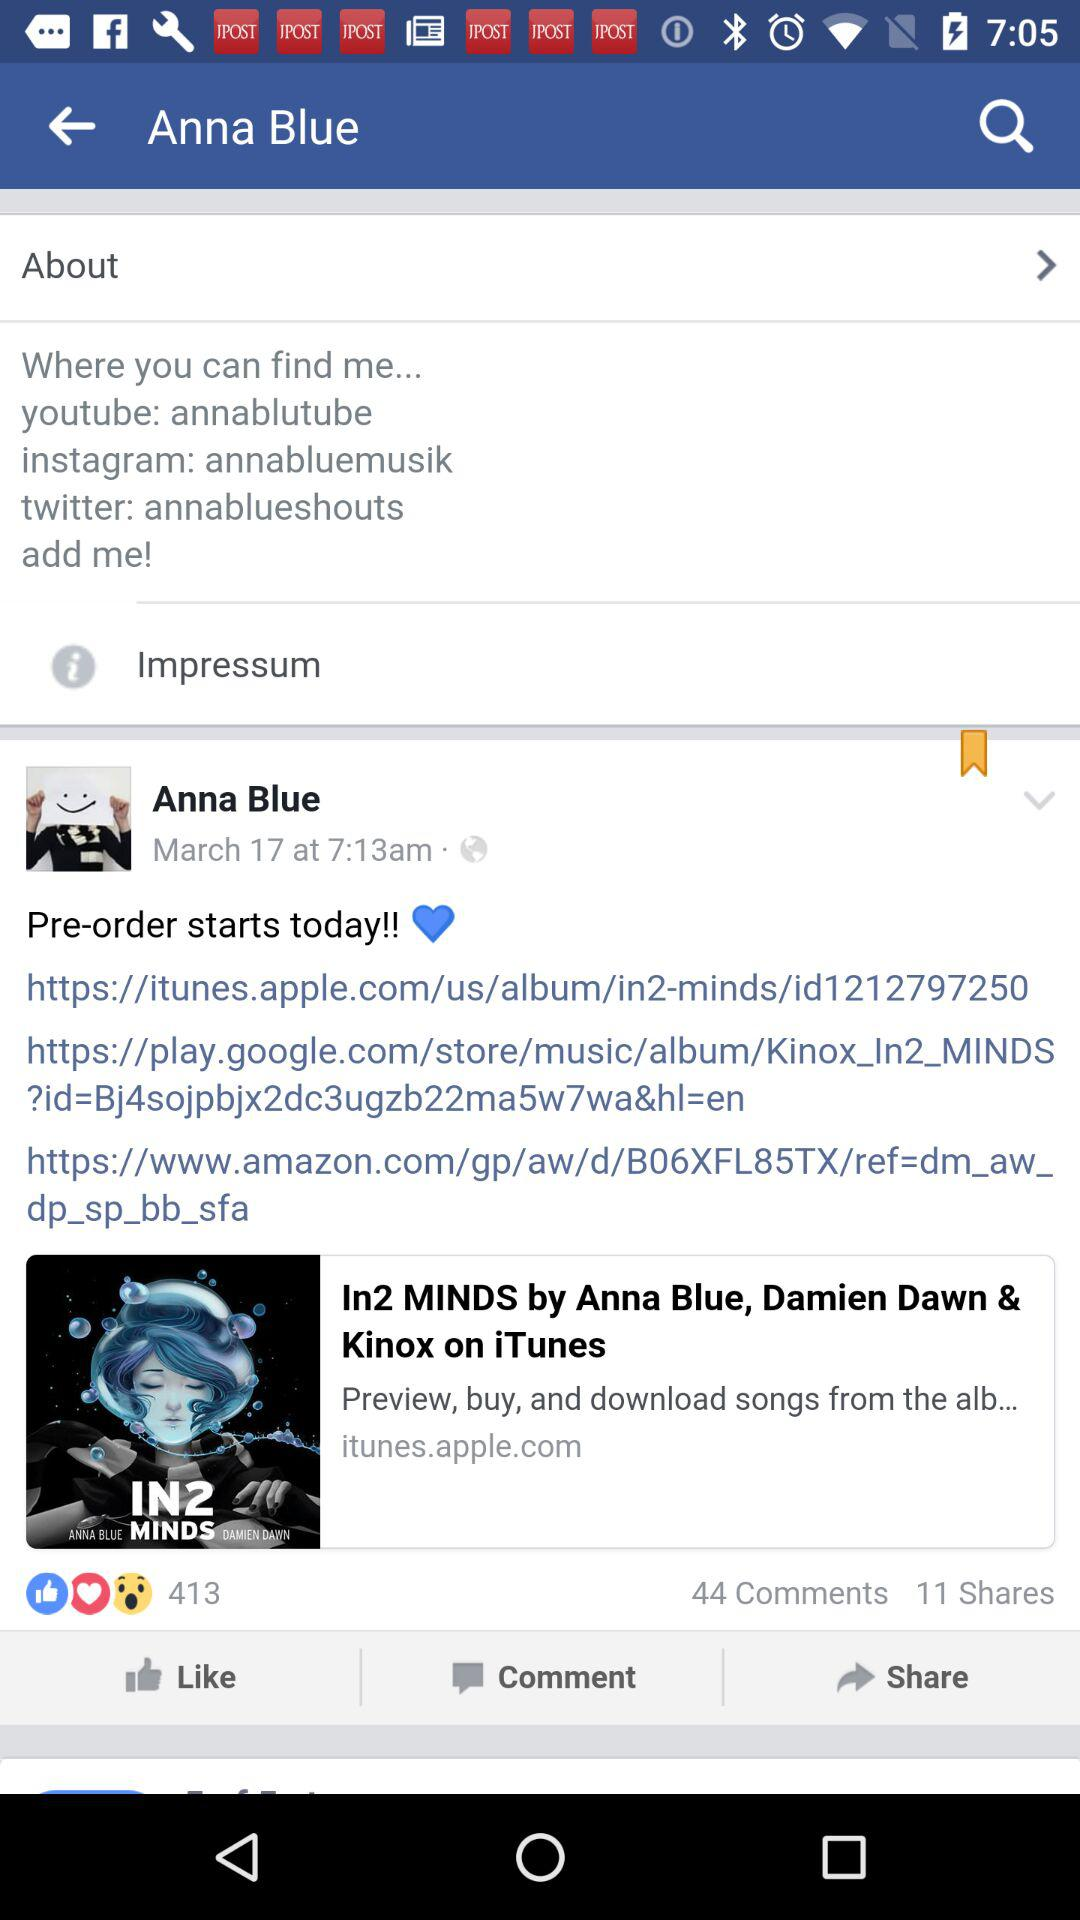How many reactions are there? There are 413 reactions. 